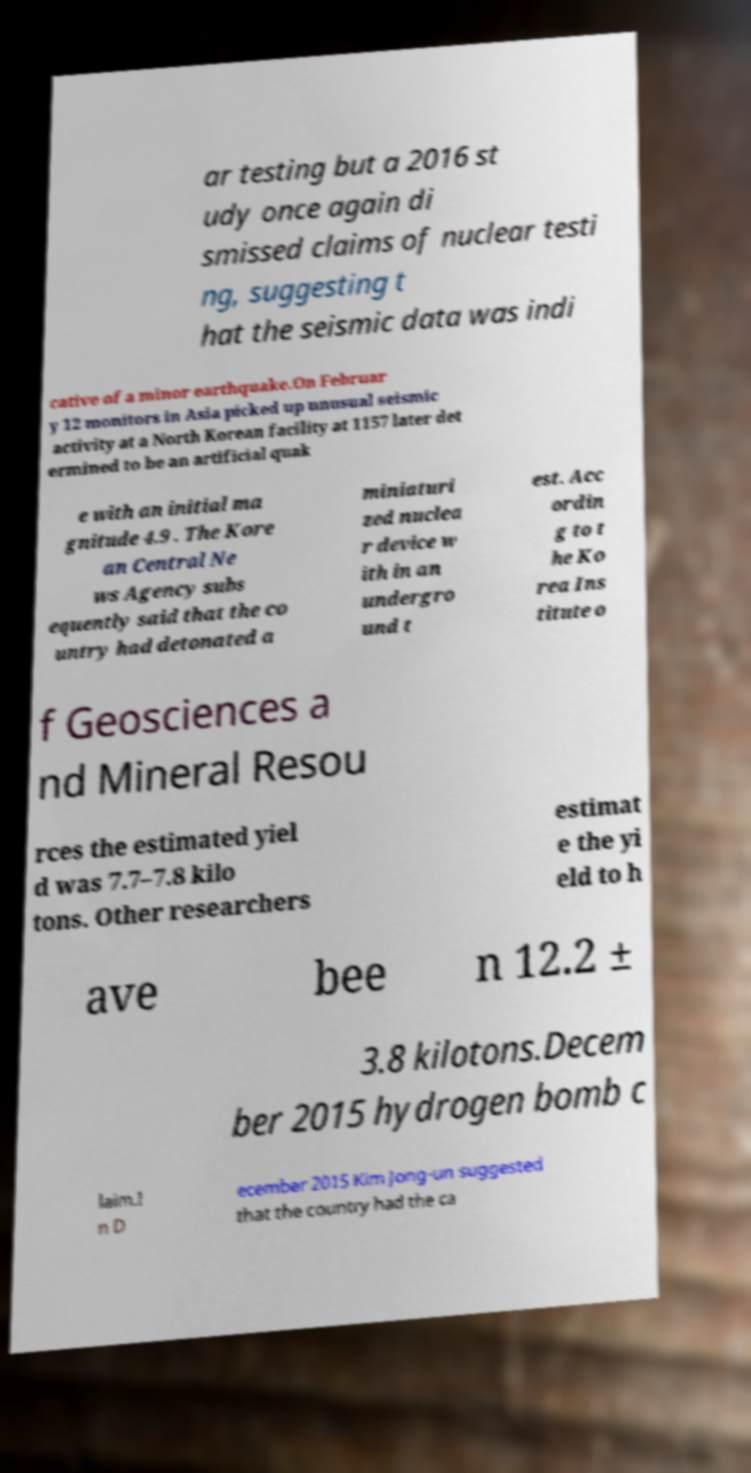I need the written content from this picture converted into text. Can you do that? ar testing but a 2016 st udy once again di smissed claims of nuclear testi ng, suggesting t hat the seismic data was indi cative of a minor earthquake.On Februar y 12 monitors in Asia picked up unusual seismic activity at a North Korean facility at 1157 later det ermined to be an artificial quak e with an initial ma gnitude 4.9 . The Kore an Central Ne ws Agency subs equently said that the co untry had detonated a miniaturi zed nuclea r device w ith in an undergro und t est. Acc ordin g to t he Ko rea Ins titute o f Geosciences a nd Mineral Resou rces the estimated yiel d was 7.7–7.8 kilo tons. Other researchers estimat e the yi eld to h ave bee n 12.2 ± 3.8 kilotons.Decem ber 2015 hydrogen bomb c laim.I n D ecember 2015 Kim Jong-un suggested that the country had the ca 